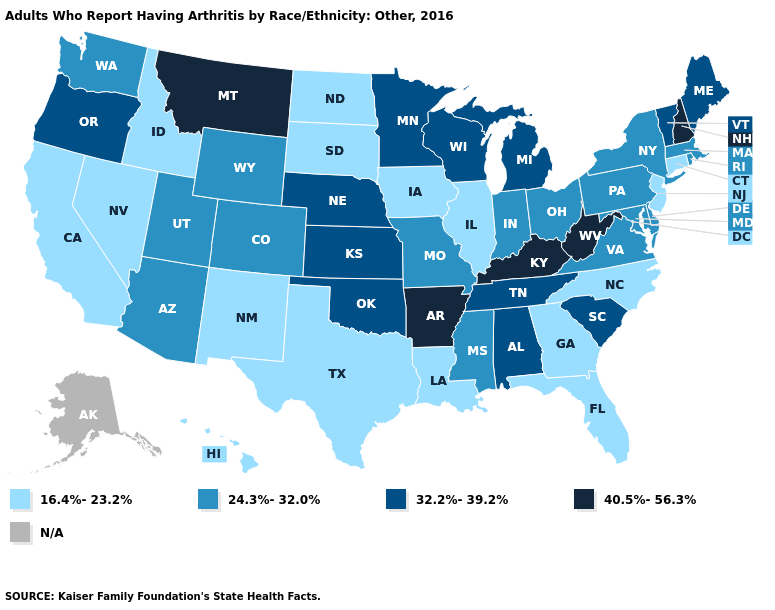What is the lowest value in the South?
Short answer required. 16.4%-23.2%. Which states have the highest value in the USA?
Short answer required. Arkansas, Kentucky, Montana, New Hampshire, West Virginia. Name the states that have a value in the range 16.4%-23.2%?
Keep it brief. California, Connecticut, Florida, Georgia, Hawaii, Idaho, Illinois, Iowa, Louisiana, Nevada, New Jersey, New Mexico, North Carolina, North Dakota, South Dakota, Texas. Which states hav the highest value in the Northeast?
Keep it brief. New Hampshire. Which states hav the highest value in the West?
Be succinct. Montana. What is the value of Pennsylvania?
Write a very short answer. 24.3%-32.0%. How many symbols are there in the legend?
Answer briefly. 5. Name the states that have a value in the range 16.4%-23.2%?
Write a very short answer. California, Connecticut, Florida, Georgia, Hawaii, Idaho, Illinois, Iowa, Louisiana, Nevada, New Jersey, New Mexico, North Carolina, North Dakota, South Dakota, Texas. What is the highest value in the USA?
Quick response, please. 40.5%-56.3%. What is the highest value in the South ?
Concise answer only. 40.5%-56.3%. Among the states that border Florida , does Alabama have the lowest value?
Write a very short answer. No. Is the legend a continuous bar?
Short answer required. No. Name the states that have a value in the range 24.3%-32.0%?
Be succinct. Arizona, Colorado, Delaware, Indiana, Maryland, Massachusetts, Mississippi, Missouri, New York, Ohio, Pennsylvania, Rhode Island, Utah, Virginia, Washington, Wyoming. What is the highest value in the USA?
Write a very short answer. 40.5%-56.3%. 